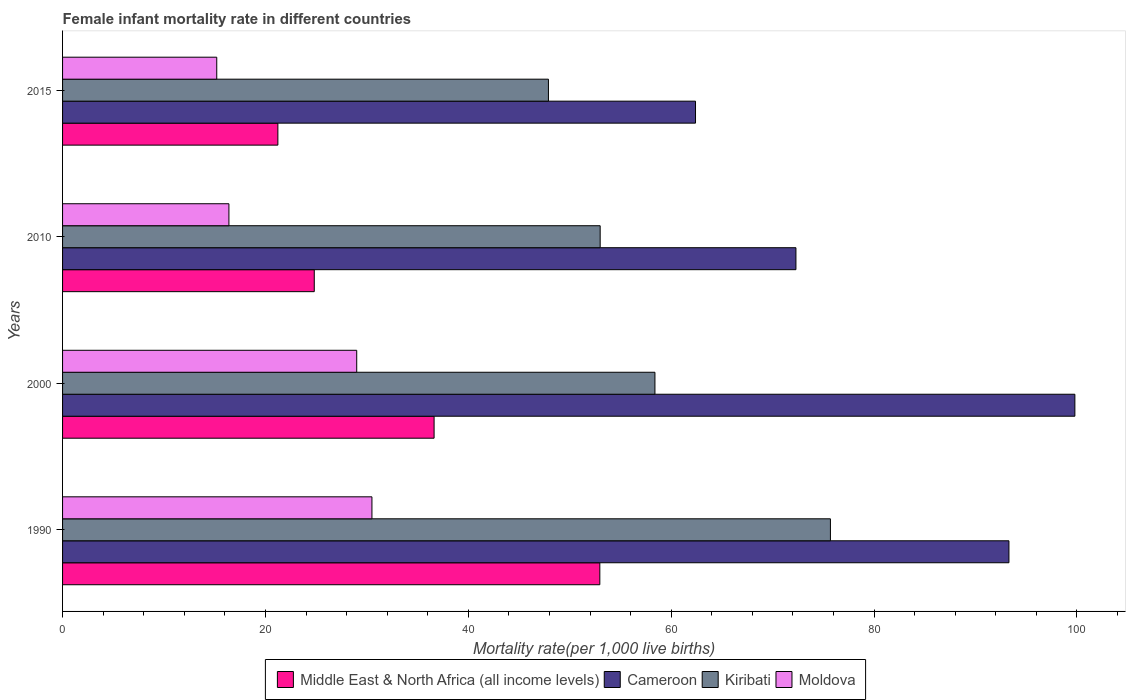Are the number of bars on each tick of the Y-axis equal?
Give a very brief answer. Yes. How many bars are there on the 3rd tick from the bottom?
Your response must be concise. 4. What is the label of the 2nd group of bars from the top?
Provide a short and direct response. 2010. In how many cases, is the number of bars for a given year not equal to the number of legend labels?
Offer a very short reply. 0. What is the female infant mortality rate in Moldova in 2000?
Provide a short and direct response. 29. Across all years, what is the maximum female infant mortality rate in Moldova?
Your answer should be very brief. 30.5. Across all years, what is the minimum female infant mortality rate in Kiribati?
Offer a terse response. 47.9. In which year was the female infant mortality rate in Moldova minimum?
Your answer should be compact. 2015. What is the total female infant mortality rate in Middle East & North Africa (all income levels) in the graph?
Your answer should be compact. 135.63. What is the difference between the female infant mortality rate in Cameroon in 2010 and the female infant mortality rate in Kiribati in 2000?
Provide a succinct answer. 13.9. What is the average female infant mortality rate in Cameroon per year?
Offer a very short reply. 81.95. In the year 2015, what is the difference between the female infant mortality rate in Kiribati and female infant mortality rate in Middle East & North Africa (all income levels)?
Make the answer very short. 26.67. What is the ratio of the female infant mortality rate in Moldova in 2010 to that in 2015?
Provide a short and direct response. 1.08. Is the female infant mortality rate in Middle East & North Africa (all income levels) in 2000 less than that in 2010?
Make the answer very short. No. What is the difference between the highest and the second highest female infant mortality rate in Middle East & North Africa (all income levels)?
Provide a short and direct response. 16.34. What is the difference between the highest and the lowest female infant mortality rate in Cameroon?
Provide a short and direct response. 37.4. In how many years, is the female infant mortality rate in Cameroon greater than the average female infant mortality rate in Cameroon taken over all years?
Offer a very short reply. 2. What does the 4th bar from the top in 1990 represents?
Provide a short and direct response. Middle East & North Africa (all income levels). What does the 4th bar from the bottom in 2015 represents?
Provide a short and direct response. Moldova. Is it the case that in every year, the sum of the female infant mortality rate in Moldova and female infant mortality rate in Cameroon is greater than the female infant mortality rate in Middle East & North Africa (all income levels)?
Your answer should be compact. Yes. Are all the bars in the graph horizontal?
Give a very brief answer. Yes. How many years are there in the graph?
Ensure brevity in your answer.  4. Does the graph contain grids?
Provide a succinct answer. No. Where does the legend appear in the graph?
Give a very brief answer. Bottom center. How many legend labels are there?
Offer a terse response. 4. How are the legend labels stacked?
Provide a short and direct response. Horizontal. What is the title of the graph?
Give a very brief answer. Female infant mortality rate in different countries. Does "European Union" appear as one of the legend labels in the graph?
Your response must be concise. No. What is the label or title of the X-axis?
Provide a succinct answer. Mortality rate(per 1,0 live births). What is the Mortality rate(per 1,000 live births) in Middle East & North Africa (all income levels) in 1990?
Make the answer very short. 52.97. What is the Mortality rate(per 1,000 live births) in Cameroon in 1990?
Offer a terse response. 93.3. What is the Mortality rate(per 1,000 live births) of Kiribati in 1990?
Your answer should be very brief. 75.7. What is the Mortality rate(per 1,000 live births) of Moldova in 1990?
Give a very brief answer. 30.5. What is the Mortality rate(per 1,000 live births) of Middle East & North Africa (all income levels) in 2000?
Your response must be concise. 36.63. What is the Mortality rate(per 1,000 live births) of Cameroon in 2000?
Offer a terse response. 99.8. What is the Mortality rate(per 1,000 live births) of Kiribati in 2000?
Keep it short and to the point. 58.4. What is the Mortality rate(per 1,000 live births) of Middle East & North Africa (all income levels) in 2010?
Make the answer very short. 24.81. What is the Mortality rate(per 1,000 live births) of Cameroon in 2010?
Your answer should be compact. 72.3. What is the Mortality rate(per 1,000 live births) of Moldova in 2010?
Keep it short and to the point. 16.4. What is the Mortality rate(per 1,000 live births) of Middle East & North Africa (all income levels) in 2015?
Make the answer very short. 21.23. What is the Mortality rate(per 1,000 live births) of Cameroon in 2015?
Your response must be concise. 62.4. What is the Mortality rate(per 1,000 live births) in Kiribati in 2015?
Offer a terse response. 47.9. Across all years, what is the maximum Mortality rate(per 1,000 live births) in Middle East & North Africa (all income levels)?
Ensure brevity in your answer.  52.97. Across all years, what is the maximum Mortality rate(per 1,000 live births) in Cameroon?
Ensure brevity in your answer.  99.8. Across all years, what is the maximum Mortality rate(per 1,000 live births) in Kiribati?
Your answer should be very brief. 75.7. Across all years, what is the maximum Mortality rate(per 1,000 live births) of Moldova?
Make the answer very short. 30.5. Across all years, what is the minimum Mortality rate(per 1,000 live births) of Middle East & North Africa (all income levels)?
Make the answer very short. 21.23. Across all years, what is the minimum Mortality rate(per 1,000 live births) of Cameroon?
Your answer should be compact. 62.4. Across all years, what is the minimum Mortality rate(per 1,000 live births) in Kiribati?
Ensure brevity in your answer.  47.9. What is the total Mortality rate(per 1,000 live births) of Middle East & North Africa (all income levels) in the graph?
Your answer should be compact. 135.63. What is the total Mortality rate(per 1,000 live births) in Cameroon in the graph?
Ensure brevity in your answer.  327.8. What is the total Mortality rate(per 1,000 live births) in Kiribati in the graph?
Keep it short and to the point. 235. What is the total Mortality rate(per 1,000 live births) of Moldova in the graph?
Keep it short and to the point. 91.1. What is the difference between the Mortality rate(per 1,000 live births) in Middle East & North Africa (all income levels) in 1990 and that in 2000?
Ensure brevity in your answer.  16.34. What is the difference between the Mortality rate(per 1,000 live births) of Cameroon in 1990 and that in 2000?
Your answer should be very brief. -6.5. What is the difference between the Mortality rate(per 1,000 live births) of Middle East & North Africa (all income levels) in 1990 and that in 2010?
Your answer should be compact. 28.15. What is the difference between the Mortality rate(per 1,000 live births) of Cameroon in 1990 and that in 2010?
Provide a short and direct response. 21. What is the difference between the Mortality rate(per 1,000 live births) in Kiribati in 1990 and that in 2010?
Your answer should be very brief. 22.7. What is the difference between the Mortality rate(per 1,000 live births) of Middle East & North Africa (all income levels) in 1990 and that in 2015?
Give a very brief answer. 31.74. What is the difference between the Mortality rate(per 1,000 live births) in Cameroon in 1990 and that in 2015?
Keep it short and to the point. 30.9. What is the difference between the Mortality rate(per 1,000 live births) in Kiribati in 1990 and that in 2015?
Give a very brief answer. 27.8. What is the difference between the Mortality rate(per 1,000 live births) of Moldova in 1990 and that in 2015?
Provide a short and direct response. 15.3. What is the difference between the Mortality rate(per 1,000 live births) in Middle East & North Africa (all income levels) in 2000 and that in 2010?
Ensure brevity in your answer.  11.81. What is the difference between the Mortality rate(per 1,000 live births) in Middle East & North Africa (all income levels) in 2000 and that in 2015?
Offer a terse response. 15.4. What is the difference between the Mortality rate(per 1,000 live births) of Cameroon in 2000 and that in 2015?
Keep it short and to the point. 37.4. What is the difference between the Mortality rate(per 1,000 live births) in Kiribati in 2000 and that in 2015?
Provide a short and direct response. 10.5. What is the difference between the Mortality rate(per 1,000 live births) of Middle East & North Africa (all income levels) in 2010 and that in 2015?
Offer a very short reply. 3.59. What is the difference between the Mortality rate(per 1,000 live births) in Cameroon in 2010 and that in 2015?
Make the answer very short. 9.9. What is the difference between the Mortality rate(per 1,000 live births) of Kiribati in 2010 and that in 2015?
Your answer should be very brief. 5.1. What is the difference between the Mortality rate(per 1,000 live births) in Middle East & North Africa (all income levels) in 1990 and the Mortality rate(per 1,000 live births) in Cameroon in 2000?
Ensure brevity in your answer.  -46.83. What is the difference between the Mortality rate(per 1,000 live births) in Middle East & North Africa (all income levels) in 1990 and the Mortality rate(per 1,000 live births) in Kiribati in 2000?
Provide a succinct answer. -5.43. What is the difference between the Mortality rate(per 1,000 live births) of Middle East & North Africa (all income levels) in 1990 and the Mortality rate(per 1,000 live births) of Moldova in 2000?
Offer a very short reply. 23.97. What is the difference between the Mortality rate(per 1,000 live births) of Cameroon in 1990 and the Mortality rate(per 1,000 live births) of Kiribati in 2000?
Your answer should be compact. 34.9. What is the difference between the Mortality rate(per 1,000 live births) in Cameroon in 1990 and the Mortality rate(per 1,000 live births) in Moldova in 2000?
Keep it short and to the point. 64.3. What is the difference between the Mortality rate(per 1,000 live births) of Kiribati in 1990 and the Mortality rate(per 1,000 live births) of Moldova in 2000?
Provide a short and direct response. 46.7. What is the difference between the Mortality rate(per 1,000 live births) of Middle East & North Africa (all income levels) in 1990 and the Mortality rate(per 1,000 live births) of Cameroon in 2010?
Offer a terse response. -19.33. What is the difference between the Mortality rate(per 1,000 live births) of Middle East & North Africa (all income levels) in 1990 and the Mortality rate(per 1,000 live births) of Kiribati in 2010?
Your response must be concise. -0.03. What is the difference between the Mortality rate(per 1,000 live births) in Middle East & North Africa (all income levels) in 1990 and the Mortality rate(per 1,000 live births) in Moldova in 2010?
Offer a very short reply. 36.57. What is the difference between the Mortality rate(per 1,000 live births) of Cameroon in 1990 and the Mortality rate(per 1,000 live births) of Kiribati in 2010?
Ensure brevity in your answer.  40.3. What is the difference between the Mortality rate(per 1,000 live births) of Cameroon in 1990 and the Mortality rate(per 1,000 live births) of Moldova in 2010?
Offer a terse response. 76.9. What is the difference between the Mortality rate(per 1,000 live births) of Kiribati in 1990 and the Mortality rate(per 1,000 live births) of Moldova in 2010?
Your answer should be very brief. 59.3. What is the difference between the Mortality rate(per 1,000 live births) of Middle East & North Africa (all income levels) in 1990 and the Mortality rate(per 1,000 live births) of Cameroon in 2015?
Give a very brief answer. -9.43. What is the difference between the Mortality rate(per 1,000 live births) of Middle East & North Africa (all income levels) in 1990 and the Mortality rate(per 1,000 live births) of Kiribati in 2015?
Provide a succinct answer. 5.07. What is the difference between the Mortality rate(per 1,000 live births) of Middle East & North Africa (all income levels) in 1990 and the Mortality rate(per 1,000 live births) of Moldova in 2015?
Provide a succinct answer. 37.77. What is the difference between the Mortality rate(per 1,000 live births) in Cameroon in 1990 and the Mortality rate(per 1,000 live births) in Kiribati in 2015?
Your response must be concise. 45.4. What is the difference between the Mortality rate(per 1,000 live births) in Cameroon in 1990 and the Mortality rate(per 1,000 live births) in Moldova in 2015?
Your answer should be compact. 78.1. What is the difference between the Mortality rate(per 1,000 live births) of Kiribati in 1990 and the Mortality rate(per 1,000 live births) of Moldova in 2015?
Make the answer very short. 60.5. What is the difference between the Mortality rate(per 1,000 live births) in Middle East & North Africa (all income levels) in 2000 and the Mortality rate(per 1,000 live births) in Cameroon in 2010?
Ensure brevity in your answer.  -35.67. What is the difference between the Mortality rate(per 1,000 live births) of Middle East & North Africa (all income levels) in 2000 and the Mortality rate(per 1,000 live births) of Kiribati in 2010?
Provide a short and direct response. -16.37. What is the difference between the Mortality rate(per 1,000 live births) in Middle East & North Africa (all income levels) in 2000 and the Mortality rate(per 1,000 live births) in Moldova in 2010?
Offer a terse response. 20.23. What is the difference between the Mortality rate(per 1,000 live births) in Cameroon in 2000 and the Mortality rate(per 1,000 live births) in Kiribati in 2010?
Make the answer very short. 46.8. What is the difference between the Mortality rate(per 1,000 live births) of Cameroon in 2000 and the Mortality rate(per 1,000 live births) of Moldova in 2010?
Provide a short and direct response. 83.4. What is the difference between the Mortality rate(per 1,000 live births) of Kiribati in 2000 and the Mortality rate(per 1,000 live births) of Moldova in 2010?
Your answer should be compact. 42. What is the difference between the Mortality rate(per 1,000 live births) in Middle East & North Africa (all income levels) in 2000 and the Mortality rate(per 1,000 live births) in Cameroon in 2015?
Make the answer very short. -25.77. What is the difference between the Mortality rate(per 1,000 live births) of Middle East & North Africa (all income levels) in 2000 and the Mortality rate(per 1,000 live births) of Kiribati in 2015?
Your response must be concise. -11.27. What is the difference between the Mortality rate(per 1,000 live births) of Middle East & North Africa (all income levels) in 2000 and the Mortality rate(per 1,000 live births) of Moldova in 2015?
Provide a short and direct response. 21.43. What is the difference between the Mortality rate(per 1,000 live births) of Cameroon in 2000 and the Mortality rate(per 1,000 live births) of Kiribati in 2015?
Make the answer very short. 51.9. What is the difference between the Mortality rate(per 1,000 live births) in Cameroon in 2000 and the Mortality rate(per 1,000 live births) in Moldova in 2015?
Give a very brief answer. 84.6. What is the difference between the Mortality rate(per 1,000 live births) in Kiribati in 2000 and the Mortality rate(per 1,000 live births) in Moldova in 2015?
Make the answer very short. 43.2. What is the difference between the Mortality rate(per 1,000 live births) in Middle East & North Africa (all income levels) in 2010 and the Mortality rate(per 1,000 live births) in Cameroon in 2015?
Your answer should be very brief. -37.59. What is the difference between the Mortality rate(per 1,000 live births) in Middle East & North Africa (all income levels) in 2010 and the Mortality rate(per 1,000 live births) in Kiribati in 2015?
Provide a short and direct response. -23.09. What is the difference between the Mortality rate(per 1,000 live births) of Middle East & North Africa (all income levels) in 2010 and the Mortality rate(per 1,000 live births) of Moldova in 2015?
Make the answer very short. 9.61. What is the difference between the Mortality rate(per 1,000 live births) in Cameroon in 2010 and the Mortality rate(per 1,000 live births) in Kiribati in 2015?
Your answer should be compact. 24.4. What is the difference between the Mortality rate(per 1,000 live births) of Cameroon in 2010 and the Mortality rate(per 1,000 live births) of Moldova in 2015?
Your response must be concise. 57.1. What is the difference between the Mortality rate(per 1,000 live births) in Kiribati in 2010 and the Mortality rate(per 1,000 live births) in Moldova in 2015?
Make the answer very short. 37.8. What is the average Mortality rate(per 1,000 live births) of Middle East & North Africa (all income levels) per year?
Provide a succinct answer. 33.91. What is the average Mortality rate(per 1,000 live births) in Cameroon per year?
Your answer should be very brief. 81.95. What is the average Mortality rate(per 1,000 live births) in Kiribati per year?
Your answer should be very brief. 58.75. What is the average Mortality rate(per 1,000 live births) of Moldova per year?
Your answer should be compact. 22.77. In the year 1990, what is the difference between the Mortality rate(per 1,000 live births) of Middle East & North Africa (all income levels) and Mortality rate(per 1,000 live births) of Cameroon?
Provide a short and direct response. -40.33. In the year 1990, what is the difference between the Mortality rate(per 1,000 live births) of Middle East & North Africa (all income levels) and Mortality rate(per 1,000 live births) of Kiribati?
Offer a terse response. -22.73. In the year 1990, what is the difference between the Mortality rate(per 1,000 live births) in Middle East & North Africa (all income levels) and Mortality rate(per 1,000 live births) in Moldova?
Offer a very short reply. 22.47. In the year 1990, what is the difference between the Mortality rate(per 1,000 live births) of Cameroon and Mortality rate(per 1,000 live births) of Kiribati?
Offer a terse response. 17.6. In the year 1990, what is the difference between the Mortality rate(per 1,000 live births) of Cameroon and Mortality rate(per 1,000 live births) of Moldova?
Keep it short and to the point. 62.8. In the year 1990, what is the difference between the Mortality rate(per 1,000 live births) in Kiribati and Mortality rate(per 1,000 live births) in Moldova?
Provide a succinct answer. 45.2. In the year 2000, what is the difference between the Mortality rate(per 1,000 live births) in Middle East & North Africa (all income levels) and Mortality rate(per 1,000 live births) in Cameroon?
Offer a very short reply. -63.17. In the year 2000, what is the difference between the Mortality rate(per 1,000 live births) of Middle East & North Africa (all income levels) and Mortality rate(per 1,000 live births) of Kiribati?
Provide a succinct answer. -21.77. In the year 2000, what is the difference between the Mortality rate(per 1,000 live births) of Middle East & North Africa (all income levels) and Mortality rate(per 1,000 live births) of Moldova?
Make the answer very short. 7.63. In the year 2000, what is the difference between the Mortality rate(per 1,000 live births) in Cameroon and Mortality rate(per 1,000 live births) in Kiribati?
Your answer should be compact. 41.4. In the year 2000, what is the difference between the Mortality rate(per 1,000 live births) of Cameroon and Mortality rate(per 1,000 live births) of Moldova?
Make the answer very short. 70.8. In the year 2000, what is the difference between the Mortality rate(per 1,000 live births) in Kiribati and Mortality rate(per 1,000 live births) in Moldova?
Give a very brief answer. 29.4. In the year 2010, what is the difference between the Mortality rate(per 1,000 live births) in Middle East & North Africa (all income levels) and Mortality rate(per 1,000 live births) in Cameroon?
Keep it short and to the point. -47.49. In the year 2010, what is the difference between the Mortality rate(per 1,000 live births) in Middle East & North Africa (all income levels) and Mortality rate(per 1,000 live births) in Kiribati?
Ensure brevity in your answer.  -28.19. In the year 2010, what is the difference between the Mortality rate(per 1,000 live births) in Middle East & North Africa (all income levels) and Mortality rate(per 1,000 live births) in Moldova?
Keep it short and to the point. 8.41. In the year 2010, what is the difference between the Mortality rate(per 1,000 live births) in Cameroon and Mortality rate(per 1,000 live births) in Kiribati?
Give a very brief answer. 19.3. In the year 2010, what is the difference between the Mortality rate(per 1,000 live births) in Cameroon and Mortality rate(per 1,000 live births) in Moldova?
Provide a succinct answer. 55.9. In the year 2010, what is the difference between the Mortality rate(per 1,000 live births) in Kiribati and Mortality rate(per 1,000 live births) in Moldova?
Provide a succinct answer. 36.6. In the year 2015, what is the difference between the Mortality rate(per 1,000 live births) in Middle East & North Africa (all income levels) and Mortality rate(per 1,000 live births) in Cameroon?
Your answer should be very brief. -41.17. In the year 2015, what is the difference between the Mortality rate(per 1,000 live births) of Middle East & North Africa (all income levels) and Mortality rate(per 1,000 live births) of Kiribati?
Offer a very short reply. -26.67. In the year 2015, what is the difference between the Mortality rate(per 1,000 live births) of Middle East & North Africa (all income levels) and Mortality rate(per 1,000 live births) of Moldova?
Your response must be concise. 6.03. In the year 2015, what is the difference between the Mortality rate(per 1,000 live births) of Cameroon and Mortality rate(per 1,000 live births) of Moldova?
Offer a terse response. 47.2. In the year 2015, what is the difference between the Mortality rate(per 1,000 live births) of Kiribati and Mortality rate(per 1,000 live births) of Moldova?
Offer a terse response. 32.7. What is the ratio of the Mortality rate(per 1,000 live births) in Middle East & North Africa (all income levels) in 1990 to that in 2000?
Your response must be concise. 1.45. What is the ratio of the Mortality rate(per 1,000 live births) in Cameroon in 1990 to that in 2000?
Provide a short and direct response. 0.93. What is the ratio of the Mortality rate(per 1,000 live births) in Kiribati in 1990 to that in 2000?
Give a very brief answer. 1.3. What is the ratio of the Mortality rate(per 1,000 live births) in Moldova in 1990 to that in 2000?
Offer a terse response. 1.05. What is the ratio of the Mortality rate(per 1,000 live births) in Middle East & North Africa (all income levels) in 1990 to that in 2010?
Your answer should be compact. 2.13. What is the ratio of the Mortality rate(per 1,000 live births) of Cameroon in 1990 to that in 2010?
Make the answer very short. 1.29. What is the ratio of the Mortality rate(per 1,000 live births) of Kiribati in 1990 to that in 2010?
Provide a short and direct response. 1.43. What is the ratio of the Mortality rate(per 1,000 live births) of Moldova in 1990 to that in 2010?
Offer a terse response. 1.86. What is the ratio of the Mortality rate(per 1,000 live births) in Middle East & North Africa (all income levels) in 1990 to that in 2015?
Offer a very short reply. 2.5. What is the ratio of the Mortality rate(per 1,000 live births) in Cameroon in 1990 to that in 2015?
Your answer should be compact. 1.5. What is the ratio of the Mortality rate(per 1,000 live births) of Kiribati in 1990 to that in 2015?
Your answer should be very brief. 1.58. What is the ratio of the Mortality rate(per 1,000 live births) of Moldova in 1990 to that in 2015?
Your answer should be very brief. 2.01. What is the ratio of the Mortality rate(per 1,000 live births) of Middle East & North Africa (all income levels) in 2000 to that in 2010?
Your answer should be compact. 1.48. What is the ratio of the Mortality rate(per 1,000 live births) in Cameroon in 2000 to that in 2010?
Provide a short and direct response. 1.38. What is the ratio of the Mortality rate(per 1,000 live births) of Kiribati in 2000 to that in 2010?
Keep it short and to the point. 1.1. What is the ratio of the Mortality rate(per 1,000 live births) of Moldova in 2000 to that in 2010?
Offer a very short reply. 1.77. What is the ratio of the Mortality rate(per 1,000 live births) of Middle East & North Africa (all income levels) in 2000 to that in 2015?
Your answer should be very brief. 1.73. What is the ratio of the Mortality rate(per 1,000 live births) in Cameroon in 2000 to that in 2015?
Offer a terse response. 1.6. What is the ratio of the Mortality rate(per 1,000 live births) in Kiribati in 2000 to that in 2015?
Your answer should be very brief. 1.22. What is the ratio of the Mortality rate(per 1,000 live births) of Moldova in 2000 to that in 2015?
Give a very brief answer. 1.91. What is the ratio of the Mortality rate(per 1,000 live births) of Middle East & North Africa (all income levels) in 2010 to that in 2015?
Your response must be concise. 1.17. What is the ratio of the Mortality rate(per 1,000 live births) of Cameroon in 2010 to that in 2015?
Keep it short and to the point. 1.16. What is the ratio of the Mortality rate(per 1,000 live births) in Kiribati in 2010 to that in 2015?
Ensure brevity in your answer.  1.11. What is the ratio of the Mortality rate(per 1,000 live births) of Moldova in 2010 to that in 2015?
Offer a terse response. 1.08. What is the difference between the highest and the second highest Mortality rate(per 1,000 live births) of Middle East & North Africa (all income levels)?
Keep it short and to the point. 16.34. What is the difference between the highest and the lowest Mortality rate(per 1,000 live births) in Middle East & North Africa (all income levels)?
Your answer should be very brief. 31.74. What is the difference between the highest and the lowest Mortality rate(per 1,000 live births) in Cameroon?
Give a very brief answer. 37.4. What is the difference between the highest and the lowest Mortality rate(per 1,000 live births) of Kiribati?
Your answer should be very brief. 27.8. 